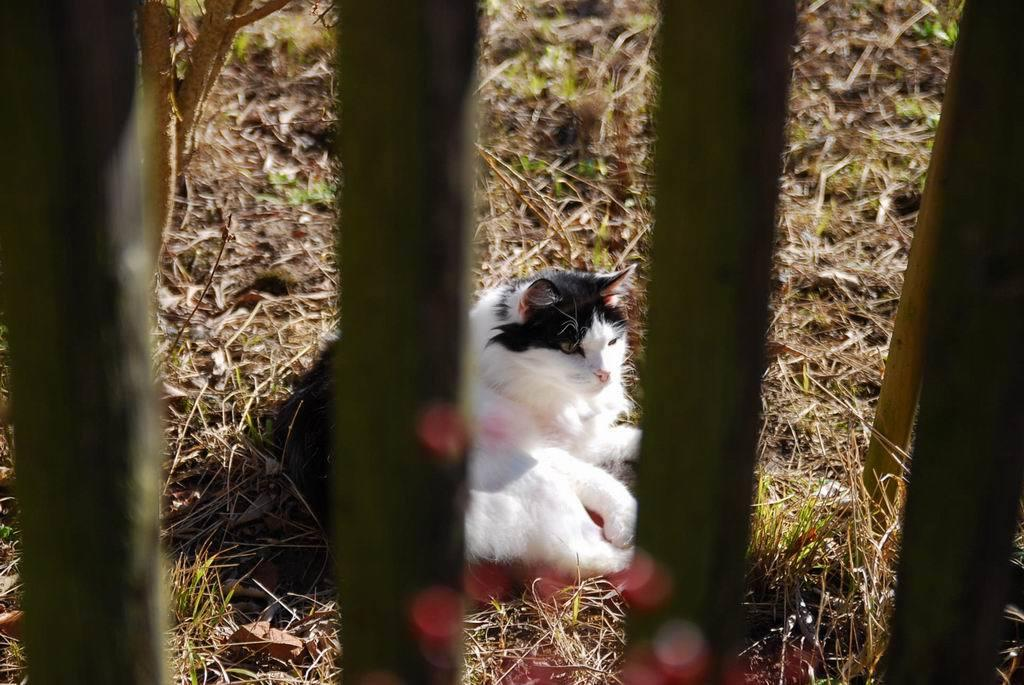What type of animal is present in the image? There is a cat in the image. Where is the cat located? The cat is on the ground in the image. What type of vegetation is on the ground? There is grass on the ground in the image. What other objects can be seen in the image? There are wooden logs in the image. What type of debt is the cat discussing with the ghost in the image? There is no mention of debt or a ghost in the image; it features a cat on the ground with grass and wooden logs. 